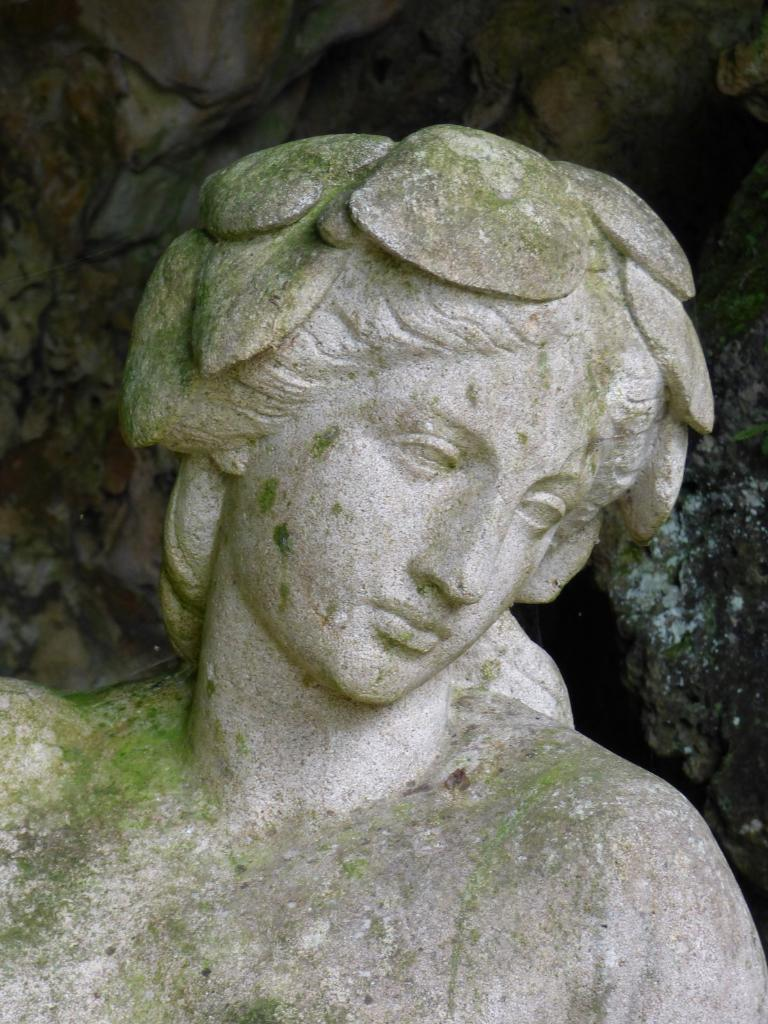What is the main subject of the image? There is a statue in the image. What does the statue resemble? The statue resembles a person. What type of potato is being used to paint the statue in the image? There is no potato or painting activity present in the image; it features a statue that resembles a person. What cast is visible on the statue's arm in the image? There is no cast visible on the statue's arm in the image; it resembles a person without any visible injuries or medical devices. 